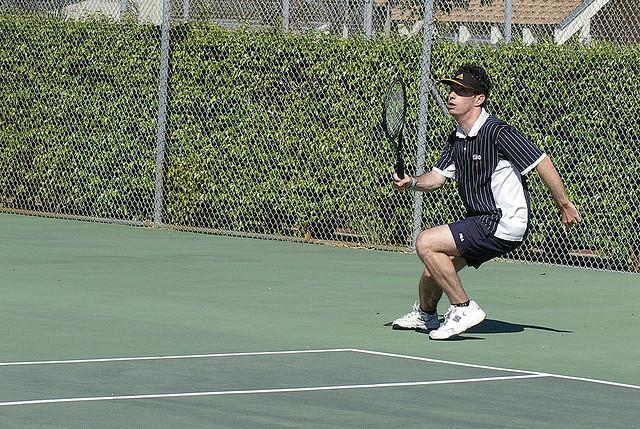How many tennis racquets are there?
Give a very brief answer. 1. 